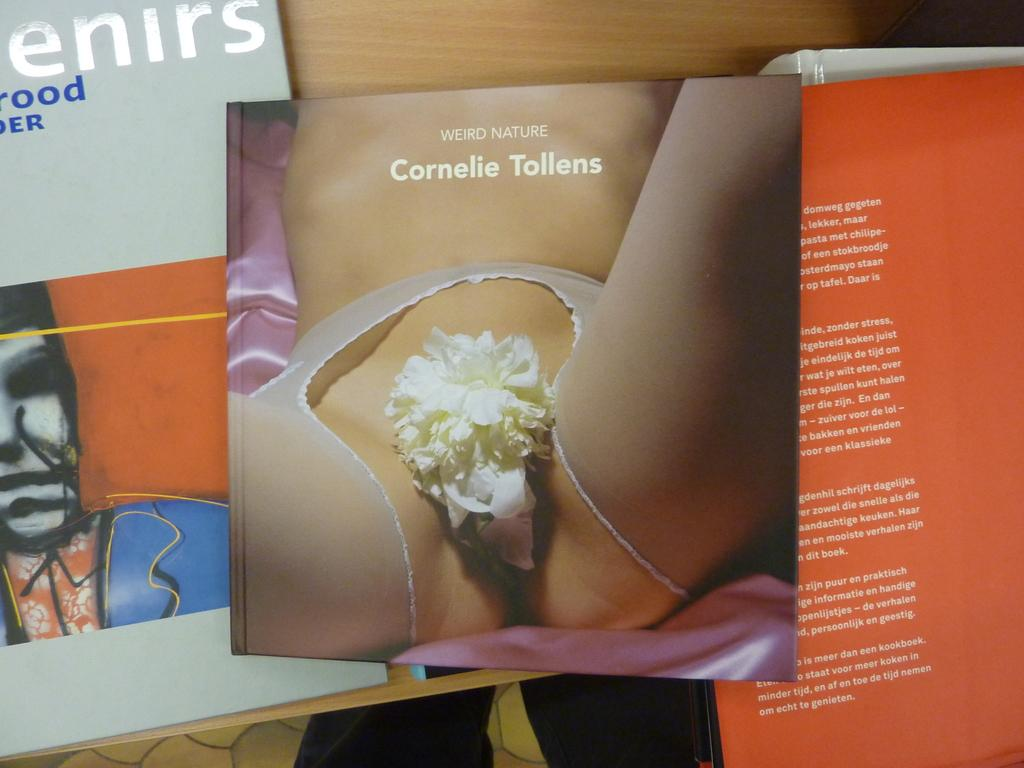Provide a one-sentence caption for the provided image. A book called Weird Nature, by Cornelie Tollens, features a woman's body on the cover. 